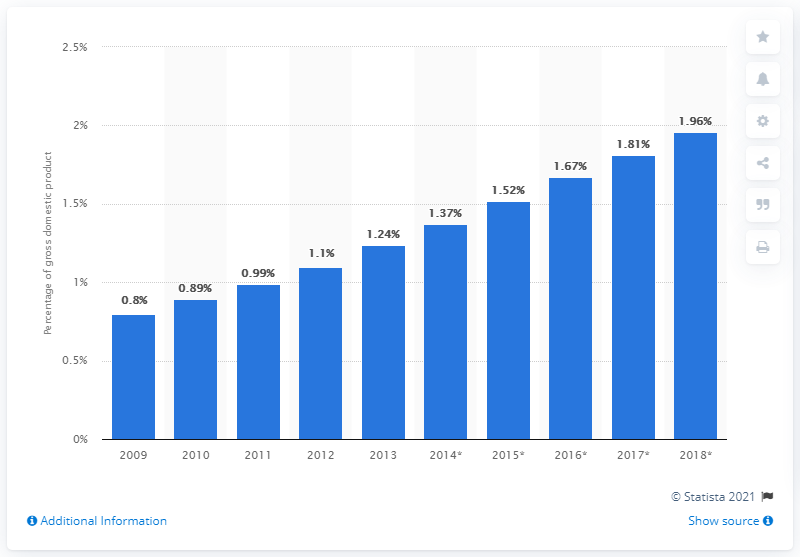Identify some key points in this picture. In 2013, B2C e-commerce accounted for approximately 1.24% of the Gross Domestic Product (GDP), according to available data. 